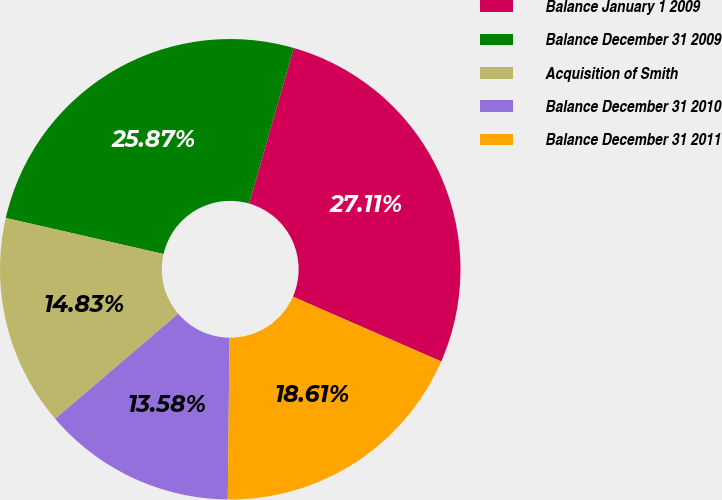Convert chart. <chart><loc_0><loc_0><loc_500><loc_500><pie_chart><fcel>Balance January 1 2009<fcel>Balance December 31 2009<fcel>Acquisition of Smith<fcel>Balance December 31 2010<fcel>Balance December 31 2011<nl><fcel>27.11%<fcel>25.87%<fcel>14.83%<fcel>13.58%<fcel>18.61%<nl></chart> 